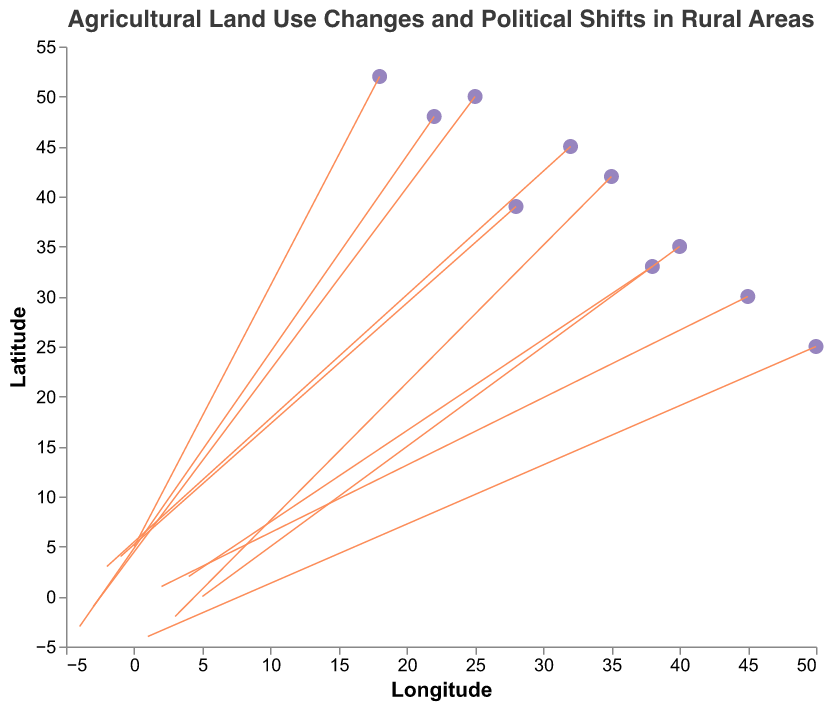What is the title of the figure? The title of the figure is prominently located at the top and reads "Agricultural Land Use Changes and Political Shifts in Rural Areas."
Answer: Agricultural Land Use Changes and Political Shifts in Rural Areas How many counties are represented in the figure? Each data point corresponds to a county, making it easy to count them by looking at the number of distinct points. There are 10 data points, each representing a different county.
Answer: 10 Which county has undergone a land use change from "Pasture to Urban"? The tooltip information includes the land use change types. By quickly hovering over each point, we find that Kern County has experienced a land use change from "Pasture to Urban."
Answer: Kern County Which data point shows the highest magnitude of land use shift in the x-direction? The x-direction shift (u) is highest for Fresno County, which has a shift of +5 in the x-direction. This is determined by looking at the u-values in the data.
Answer: Fresno County Which county has a political shift from "Moderate to Liberal"? By examining the tooltip information for political shift, we find that there are several counties. They are Siskiyou County, Sonoma County, and Napa County.
Answer: Siskiyou County, Sonoma County, Napa County Which counties have experienced a political shift toward Conservatism? From the tooltip information for political shifts, the counties with a shift toward Conservatism are Kern County (Liberal to Conservative), Fresno County (Moderate to Conservative), and Tulare County (Liberal to Conservative).
Answer: Kern County, Fresno County, Tulare County What is the average u-component of all data points? Summing up all the u-values: 3 + (-1) + 2 + (-4) + 5 + (-2) + 1 + 0 + 4 + (-3) = 5. Dividing by the number of data points (10), we get an average of 0.5.
Answer: 0.5 Compare the magnitude of the v-direction changes between Humboldt County and Tulare County. Which has the greater magnitude? Humboldt County has a v-component of -2, and Tulare County has a v-component of -4. The magnitudes are 2 and 4, respectively. Tulare County has the greater magnitude.
Answer: Tulare County Which county shows the smallest shift in land use, and what is the shift? The smallest shift is a tie between Sonoma County, which has a u-component of 0 and a v-component of 5, indicating no shift in the x-direction.
Answer: Sonoma County with (0, 5) Determine the sum of the y-components (v) for the counties that experienced a political shift from Conservative to Moderate. The counties with this shift are Humboldt County (-2) and Butte County (+3). Summing these values: -2 + 3 = 1.
Answer: 1 